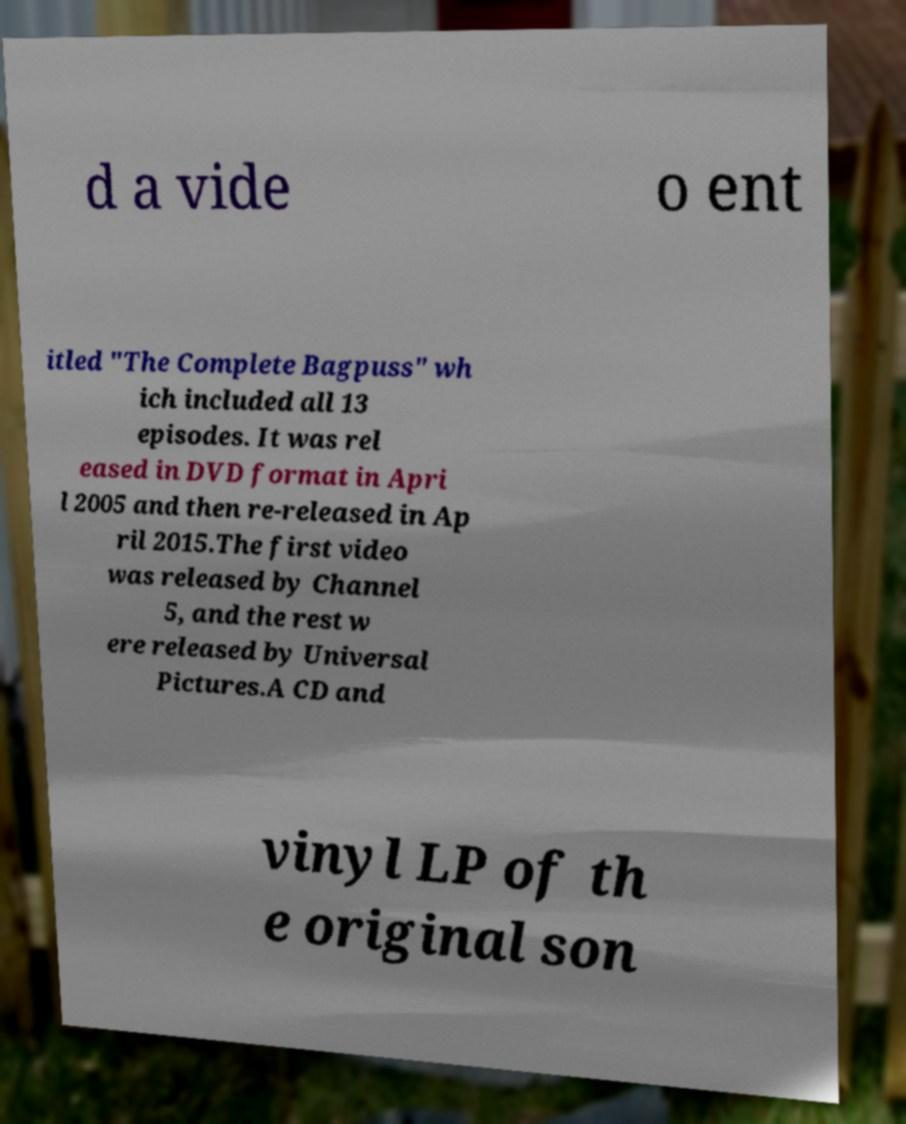There's text embedded in this image that I need extracted. Can you transcribe it verbatim? d a vide o ent itled "The Complete Bagpuss" wh ich included all 13 episodes. It was rel eased in DVD format in Apri l 2005 and then re-released in Ap ril 2015.The first video was released by Channel 5, and the rest w ere released by Universal Pictures.A CD and vinyl LP of th e original son 